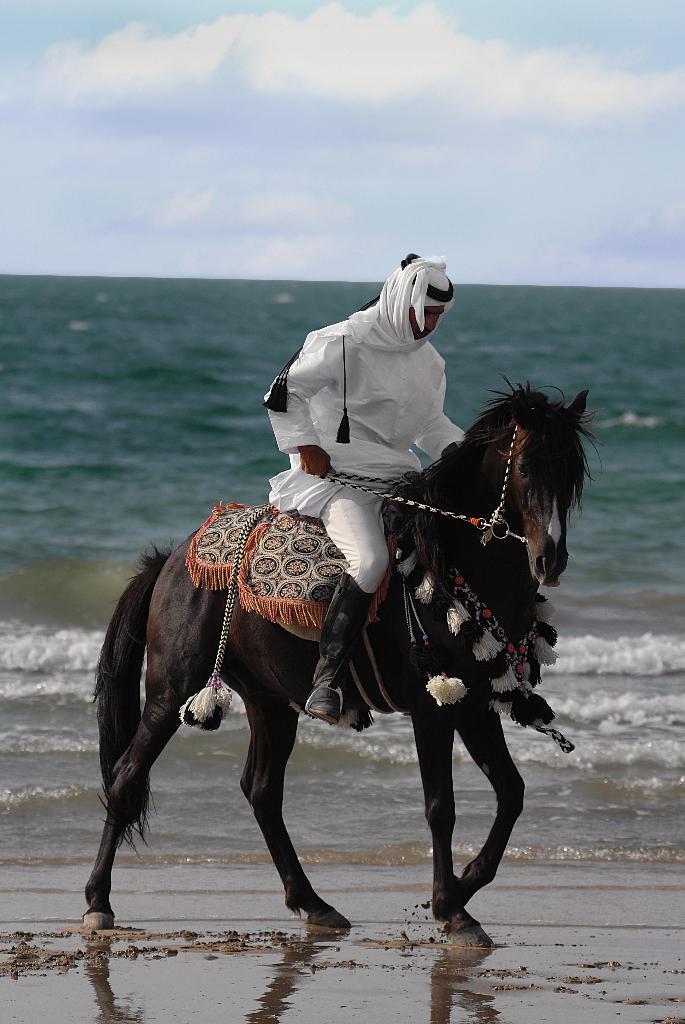Can you describe this image briefly? This image is taken near the sea shore where there is a man sitting on the horse. And there is a sea water behind,At the background. A man is wearing a white dress and a black shoes. A horse is decorated with its things. And at the top of the image i can see a sky with clouds. 